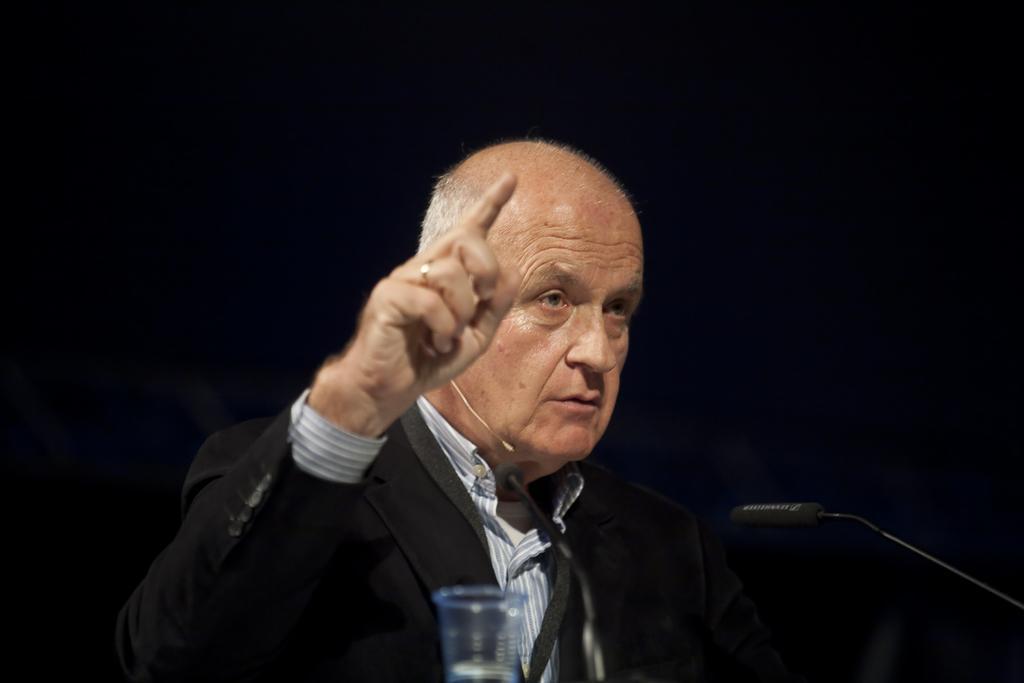Describe this image in one or two sentences. In this image we can see a person speaking into a microphone. There is a dark background in the image. There is a glass at the bottom of the image. 